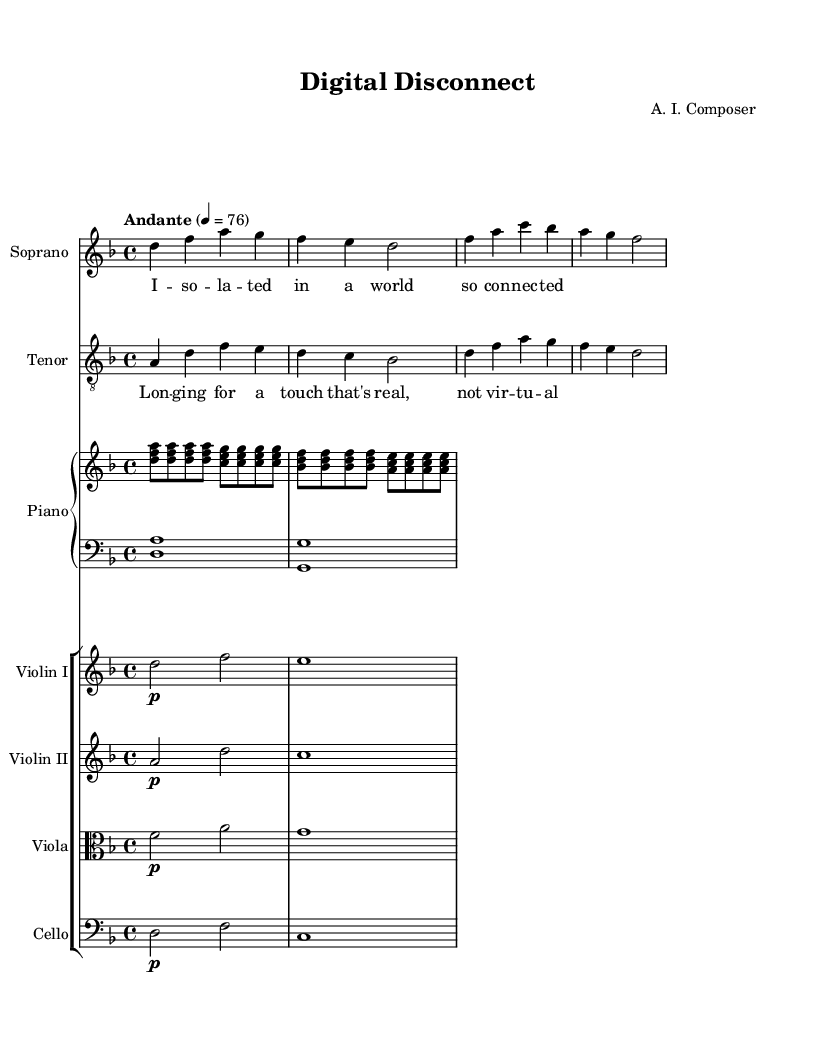What is the title of this opera? The title is "Digital Disconnect", which can be found at the top of the sheet music under the header section.
Answer: Digital Disconnect What is the key signature of this music? The key signature is indicated in the global section where it states "d minor," which means there are one flat (B flat) in the key.
Answer: D minor What is the time signature of this piece? The time signature appears at the beginning of the global section as "4/4," meaning there are four beats in a measure and the quarter note gets one beat.
Answer: 4/4 What is the tempo marking for this piece? The tempo marking is "Andante," which is found in the global section where it specifies the speed of the piece.
Answer: Andante How many measures are in the soprano part? By counting the distinct groupings of notes in the sopranoNotes section, we can determine there are five measures present.
Answer: Five What is the dynamic marking for the violin I part? In the violin I part, the dynamic marking is indicated by "p," which stands for piano, meaning to play softly.
Answer: Piano What theme does the lyric of the tenor voice suggest? The lyrics of the tenor part discuss longing for genuine human connection, contrasting it with a virtual experience, showing a theme of disconnection in the digital age.
Answer: Longing for real connection 